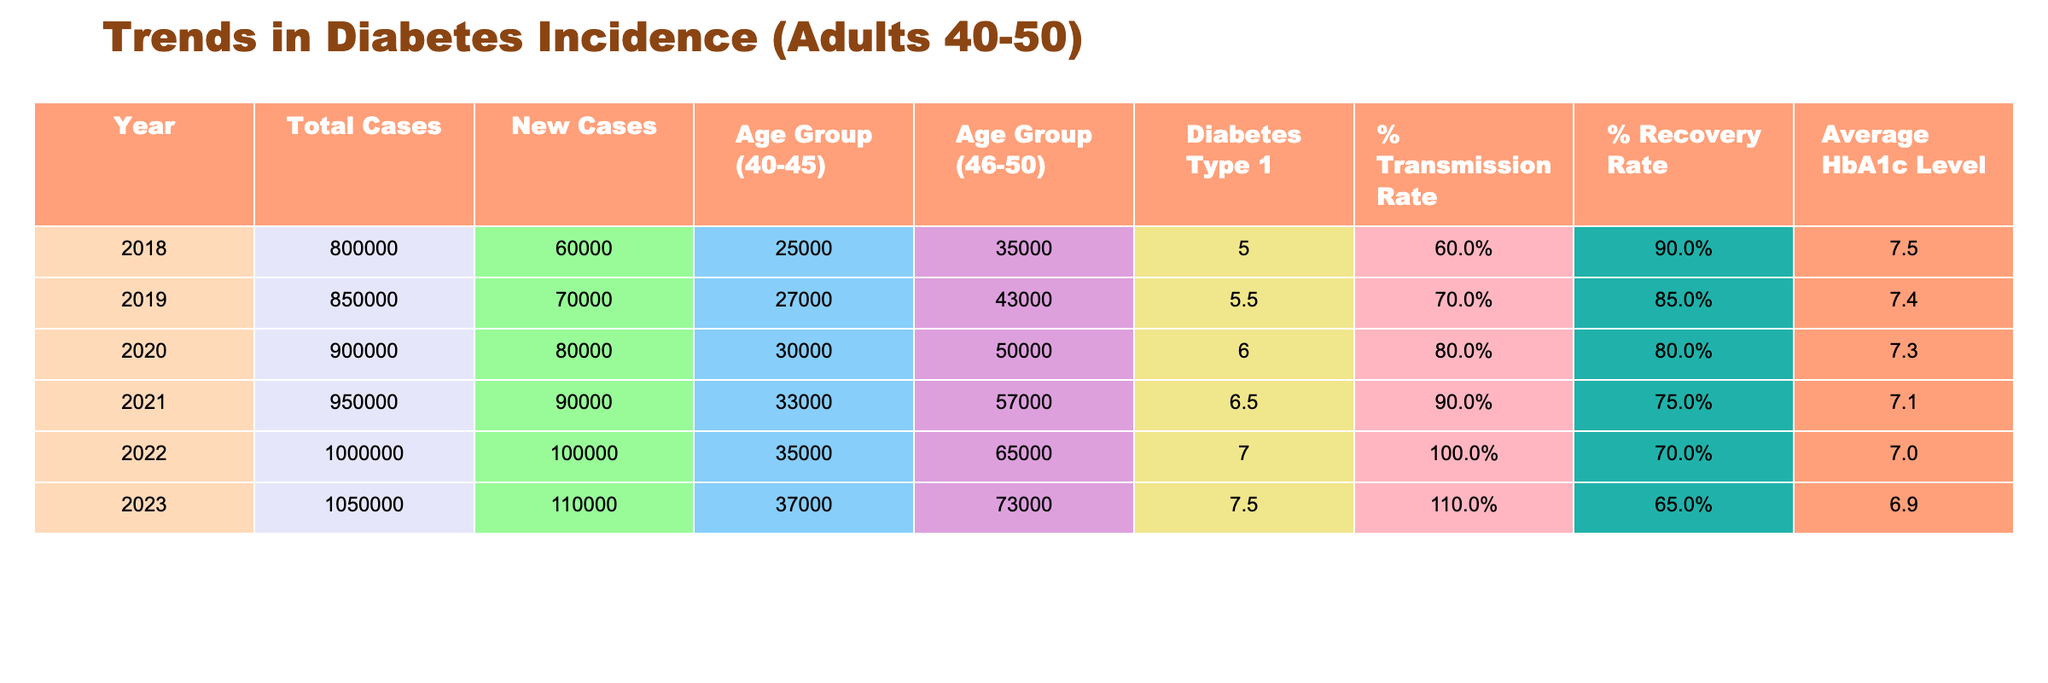What was the total number of diabetes cases in 2021? The total number of diabetes cases can be found in the "Total Cases" column for the year 2021. Looking at that row, the total number is 950,000.
Answer: 950,000 What is the percentage recovery rate in 2023? The percentage recovery rate for 2023 can be found in the "% Recovery Rate" column. The value for 2023 is 0.65, which means a 65% recovery rate.
Answer: 65% In which year did the new cases peak, and what was the number of new cases? To find the peak of new cases, we can look at the "New Cases" column across the years. The highest value in this column is 110,000, which occurred in 2023.
Answer: 2023, 110,000 What is the change in the average HbA1c level from 2018 to 2023? The average HbA1c level in 2018 is 7.5, and in 2023, it is 6.9. To find the change, we subtract 6.9 from 7.5, which gives 7.5 - 6.9 = 0.6. Thus, the average HbA1c level decreased by 0.6 over these years.
Answer: 0.6 Did the percentage transmission rate increase from 2020 to 2021? In 2020, the percentage transmission rate is 0.8, and in 2021, it is 0.9. Since 0.9 is greater than 0.8, the transmission rate indeed increased from 2020 to 2021.
Answer: Yes What was the total number of cases for the age group 46-50 in 2022? To find the total number of cases for the age group 46-50 in 2022, we look at the "Age Group (46-50)" column for the year 2022, which shows 65,000.
Answer: 65,000 What is the average percentage of diabetes type 1 cases from 2018 to 2023? We can find the average percentage of diabetes type 1 by first summing the values from the "Diabetes Type 1" column: 5 + 5.5 + 6 + 6.5 + 7 + 7.5 = 37. Then, we divide by 6 (the number of years) to get the average: 37 / 6 = 6.17.
Answer: 6.17 Was there an increase in new cases from 2020 to 2021, and if so, by how much? In 2020, new cases were 80,000, and in 2021, they increased to 90,000. The difference is 90,000 - 80,000 = 10,000, indicating an increase.
Answer: Yes, by 10,000 How did the number of cases in the age group 40-45 change from 2019 to 2023? In 2019, the number of cases in the 40-45 age group was 27,000, and in 2023 it is 37,000. The change can be calculated as 37,000 - 27,000 = 10,000. Therefore, it increased by 10,000 cases.
Answer: Increased by 10,000 